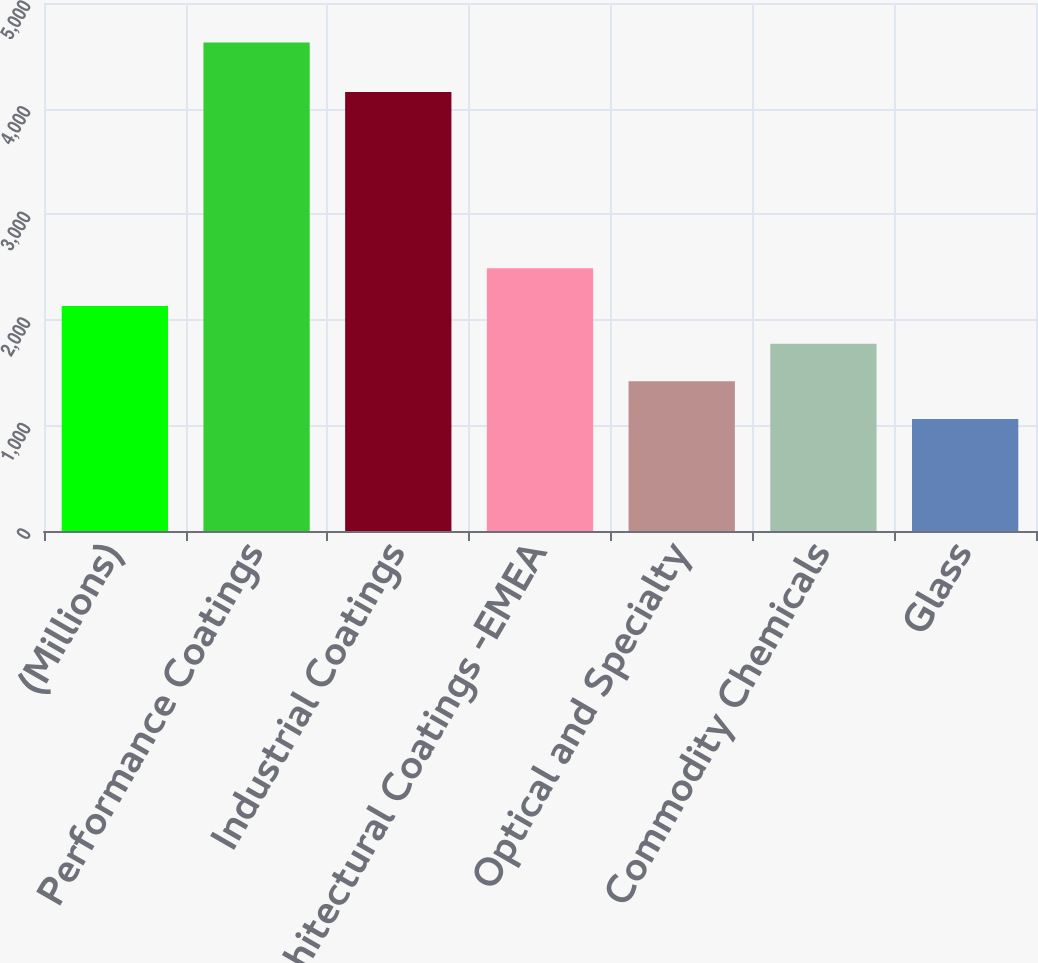Convert chart to OTSL. <chart><loc_0><loc_0><loc_500><loc_500><bar_chart><fcel>(Millions)<fcel>Performance Coatings<fcel>Industrial Coatings<fcel>Architectural Coatings -EMEA<fcel>Optical and Specialty<fcel>Commodity Chemicals<fcel>Glass<nl><fcel>2130.5<fcel>4626<fcel>4158<fcel>2487<fcel>1417.5<fcel>1774<fcel>1061<nl></chart> 